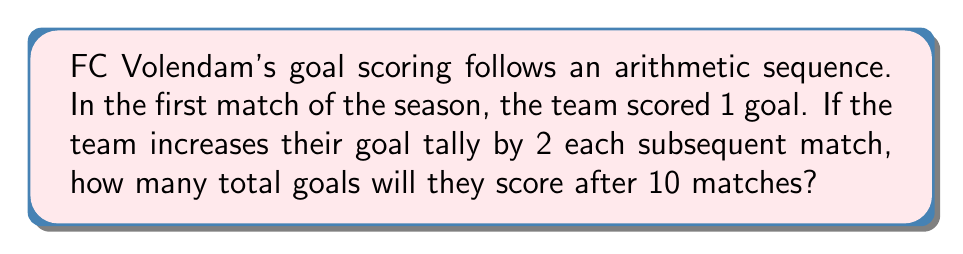Help me with this question. Let's approach this step-by-step using the arithmetic sequence formula:

1) The arithmetic sequence formula for the sum of terms is:

   $$S_n = \frac{n}{2}(a_1 + a_n)$$

   Where $S_n$ is the sum of $n$ terms, $a_1$ is the first term, and $a_n$ is the last term.

2) We know:
   - $a_1 = 1$ (first match: 1 goal)
   - $n = 10$ (number of matches)
   - The common difference $d = 2$ (increase by 2 goals each match)

3) To find $a_n$ (goals in the 10th match):
   $$a_n = a_1 + (n-1)d$$
   $$a_{10} = 1 + (10-1)2 = 1 + 18 = 19$$

4) Now we can apply the sum formula:
   $$S_{10} = \frac{10}{2}(1 + 19)$$
   $$S_{10} = 5(20) = 100$$

Therefore, FC Volendam will score a total of 100 goals after 10 matches.
Answer: 100 goals 